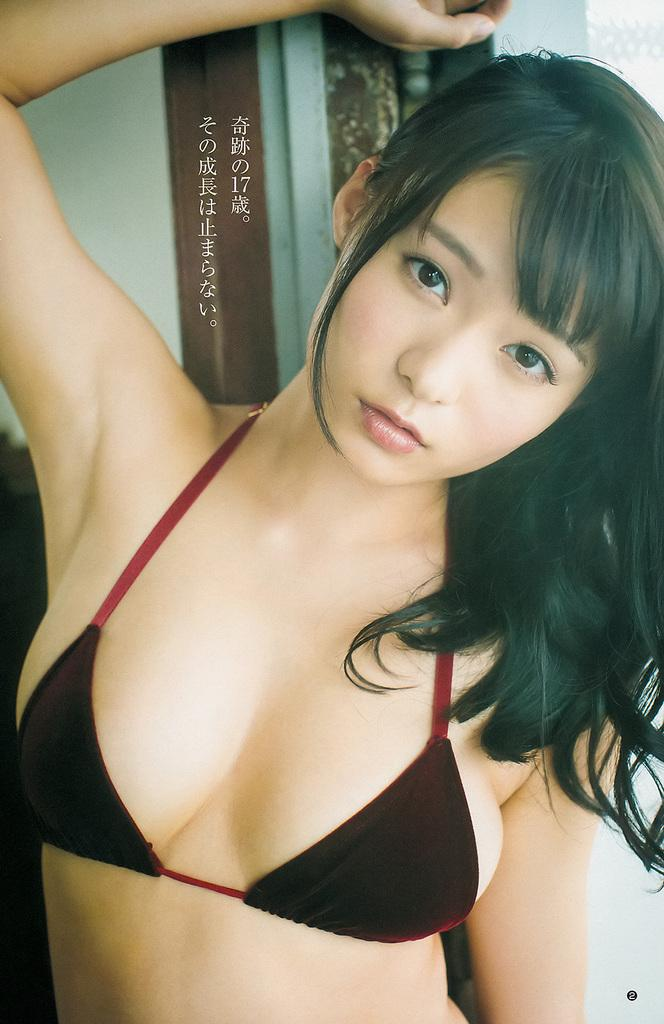What is the main subject in the image? There is a woman standing in the image. What can be seen behind the woman? There is a wall behind the woman. Are there any decorations or items on the wall? Yes, there are objects on the wall. Can you describe the objects on the wall? The objects on the wall have text on them. How many ladybugs are crawling on the woman's shoulder in the image? There are no ladybugs visible in the image. What type of stick is the woman holding in the image? The woman is not holding any stick in the image. 